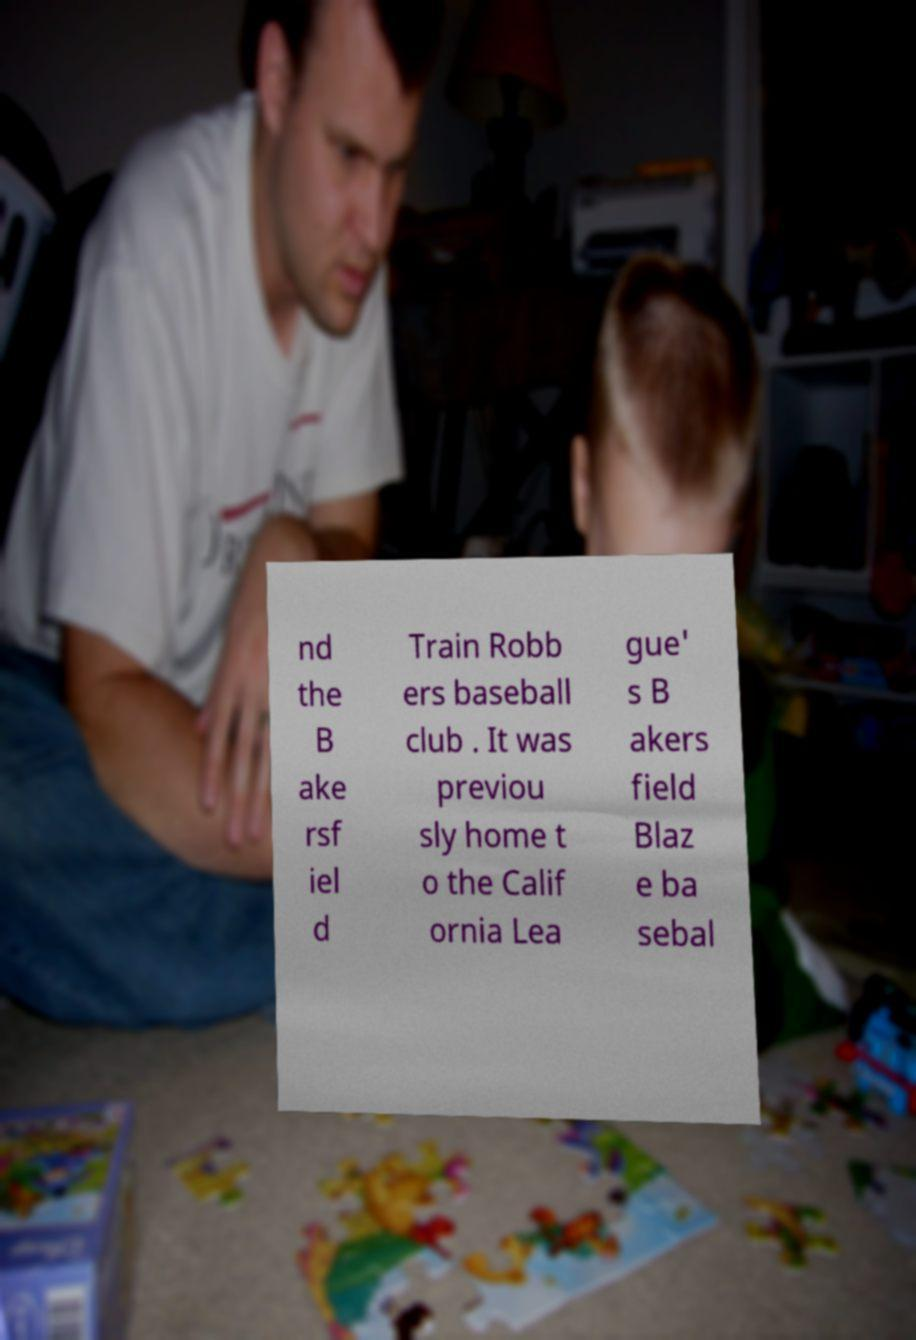Please read and relay the text visible in this image. What does it say? nd the B ake rsf iel d Train Robb ers baseball club . It was previou sly home t o the Calif ornia Lea gue' s B akers field Blaz e ba sebal 